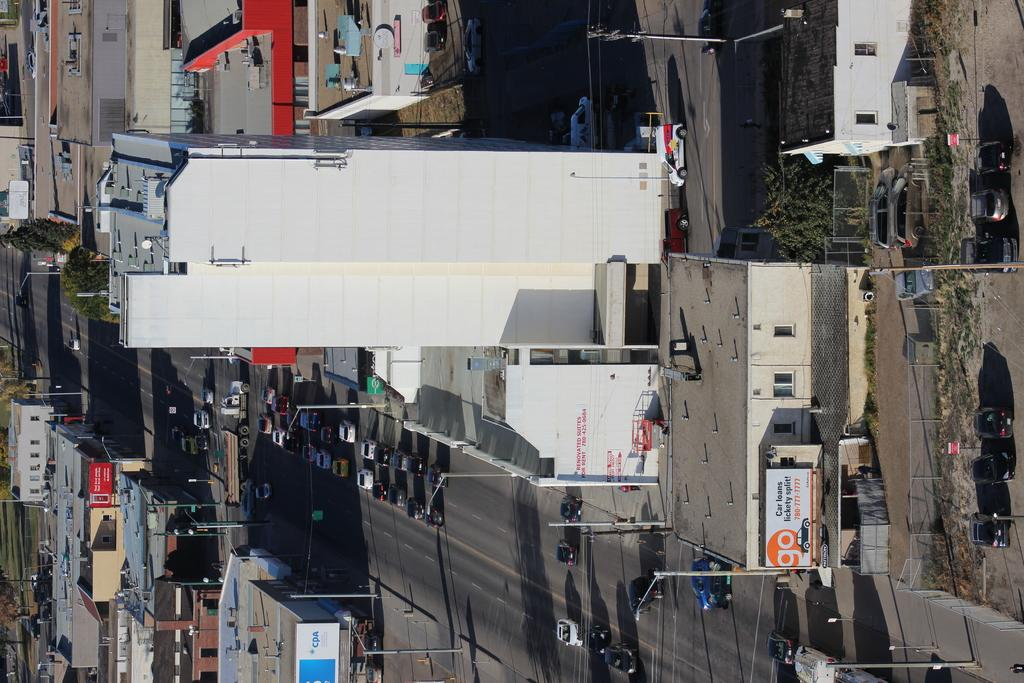What type of structures can be seen in the image? There are buildings in the image. What is happening on the roads in the image? Vehicles are present on the roads in the image. What is separating the different areas in the image? There is a fence in the image. What type of natural elements can be seen in the image? Trees and plants are visible in the image. What is providing illumination in the image? Pole lights are in the image. What type of signage or information is present in the image? Boards are present in the image. What other objects can be seen on the ground in the image? There are other objects on the ground in the image. Can you see a fight breaking out between people in the image? There is no fight present in the image. What type of stove is being used to cook in the image? There is no stove present in the image. 